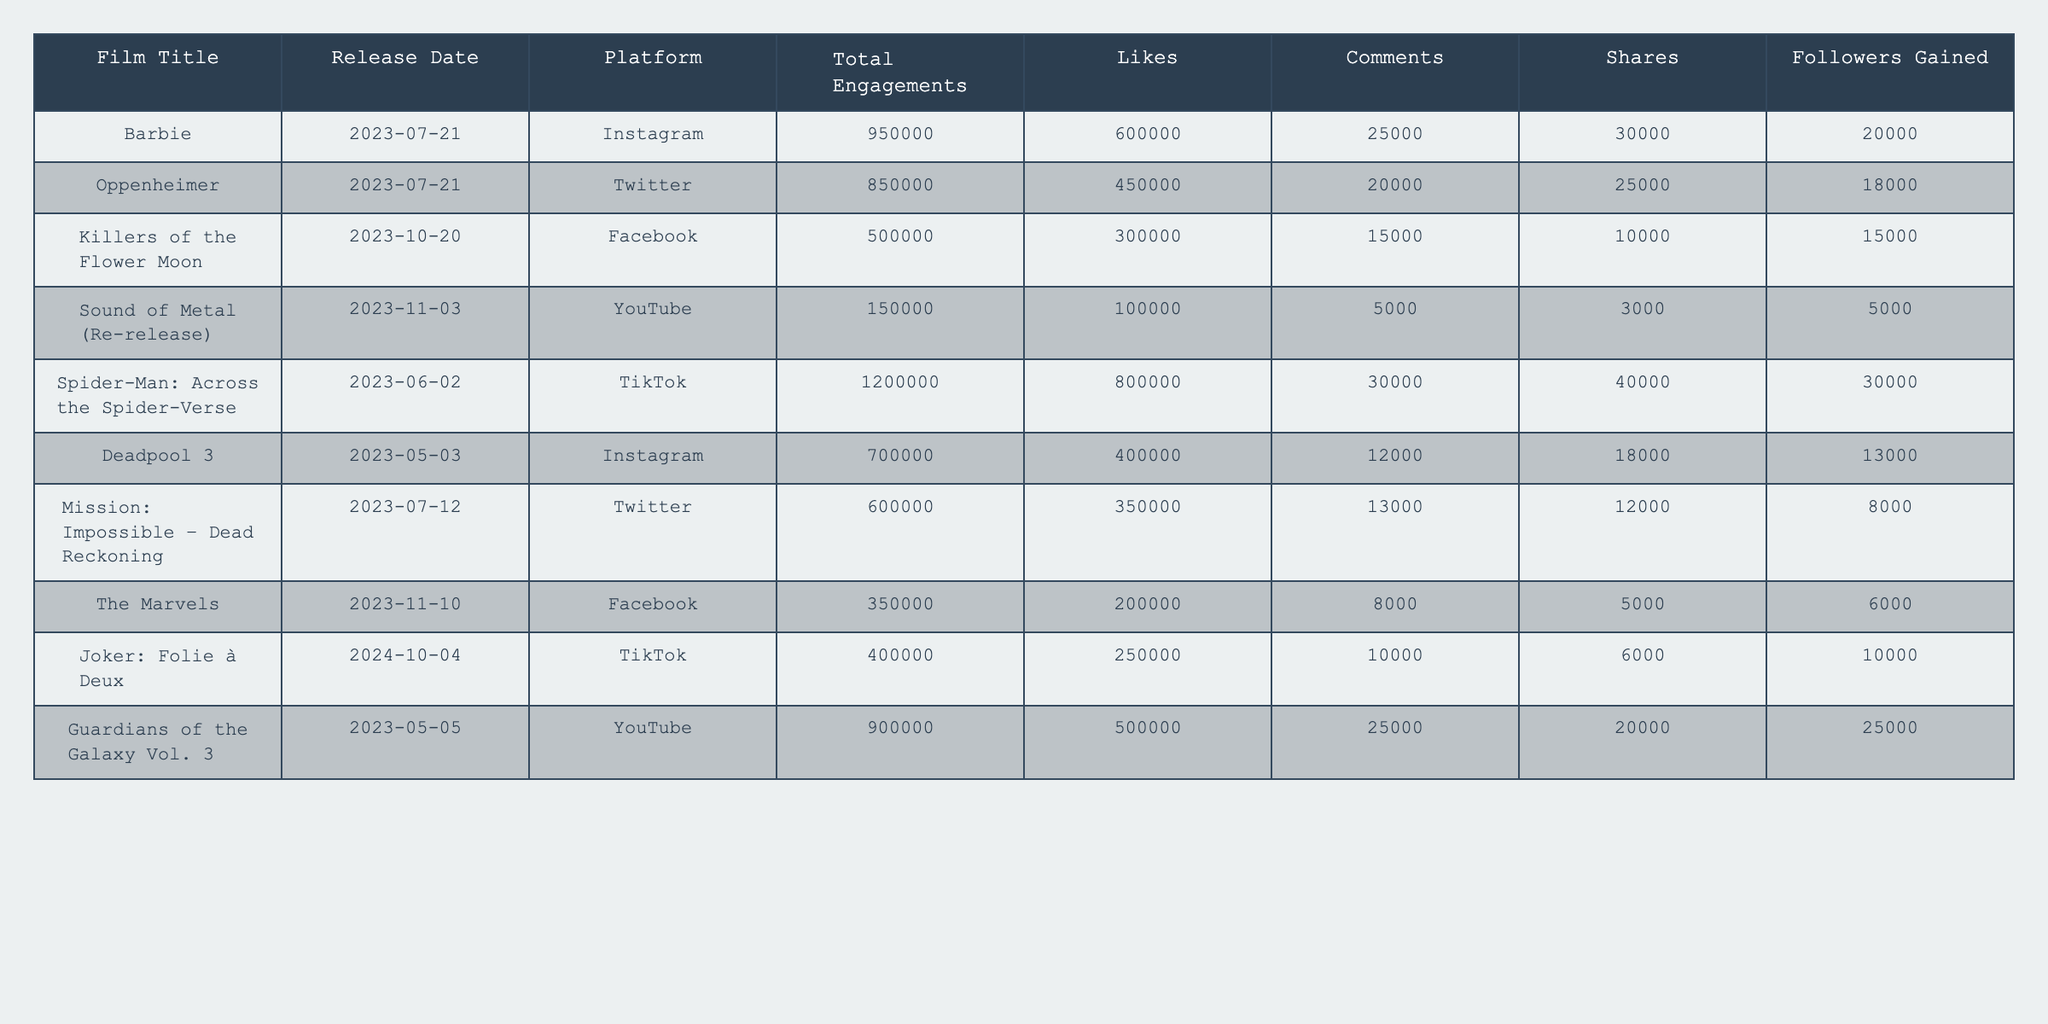What is the total engagement for "Spider-Man: Across the Spider-Verse"? The table shows that "Spider-Man: Across the Spider-Verse" has a total engagement of 1,200,000.
Answer: 1,200,000 Which film gained the most followers? Looking at the "Followers Gained" column, "Spider-Man: Across the Spider-Verse" gained the highest number of followers with 30,000.
Answer: 30,000 How many total engagements did the films released on July 21, 2023, receive combined? The films released on July 21, 2023, are "Barbie" (950,000) and "Oppenheimer" (850,000). Adding these gives 950,000 + 850,000 = 1,800,000 for combined total engagements.
Answer: 1,800,000 Is the number of likes for "Deadpool 3" greater than that for "Killers of the Flower Moon"? "Deadpool 3" has 400,000 likes while "Killers of the Flower Moon" has 300,000 likes. Since 400,000 is greater than 300,000, the statement is true.
Answer: Yes What is the average number of shares across all films? To find the average shares, first sum up the shares: 30,000 + 25,000 + 10,000 + 3,000 + 40,000 + 18,000 + 12,000 + 5,000 + 6,000 + 20,000 = 169,000. Then divide by the number of films, which is 10. Thus, the average shares is 169,000 / 10 = 16,900.
Answer: 16,900 Which platform had the least total engagement, and what was the value? The platform with the least total engagement is YouTube with "Sound of Metal" re-release, which received 150,000 total engagements.
Answer: YouTube, 150,000 What is the difference in total engagements between "Guardians of the Galaxy Vol. 3" and "The Marvels"? "Guardians of the Galaxy Vol. 3" has 900,000 engagements and "The Marvels" has 350,000 engagements. The difference is 900,000 - 350,000 = 550,000.
Answer: 550,000 Which film had more likes, "Joker: Folie à Deux" or "Sound of Metal" (Re-release)? "Joker: Folie à Deux" has 250,000 likes, while "Sound of Metal" has 100,000 likes. Therefore, "Joker: Folie à Deux" has more likes.
Answer: Joker: Folie à Deux What percentage of total engagements did "Killers of the Flower Moon" account for across all films? The total engagements across all films is 950,000 + 850,000 + 500,000 + 150,000 + 1,200,000 + 700,000 + 600,000 + 350,000 + 400,000 + 900,000 = 5,200,000. "Killers of the Flower Moon" has 500,000 engagements. The percentage is (500,000 / 5,200,000) * 100 = approximately 9.62%.
Answer: Approximately 9.62% Which film had the most comments compared to the others? By comparing the comments column, "Spider-Man: Across the Spider-Verse" has 30,000 comments, which is the highest number among all the films listed.
Answer: Spider-Man: Across the Spider-Verse 